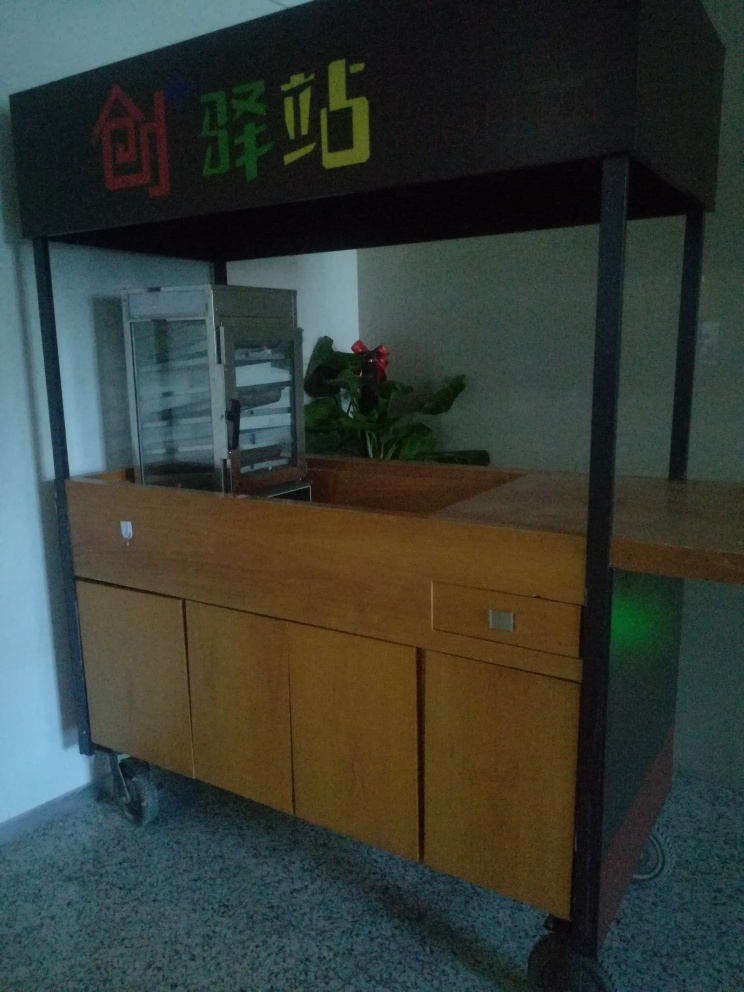What might be the function of the counter in the image? The counter in the image seems to be a reception area, as suggested by its design, the presence of a sign that could denote a company or department name, and small details such as the pamphlets or documents on the counter and the plant, which add a welcoming touch to the space. 